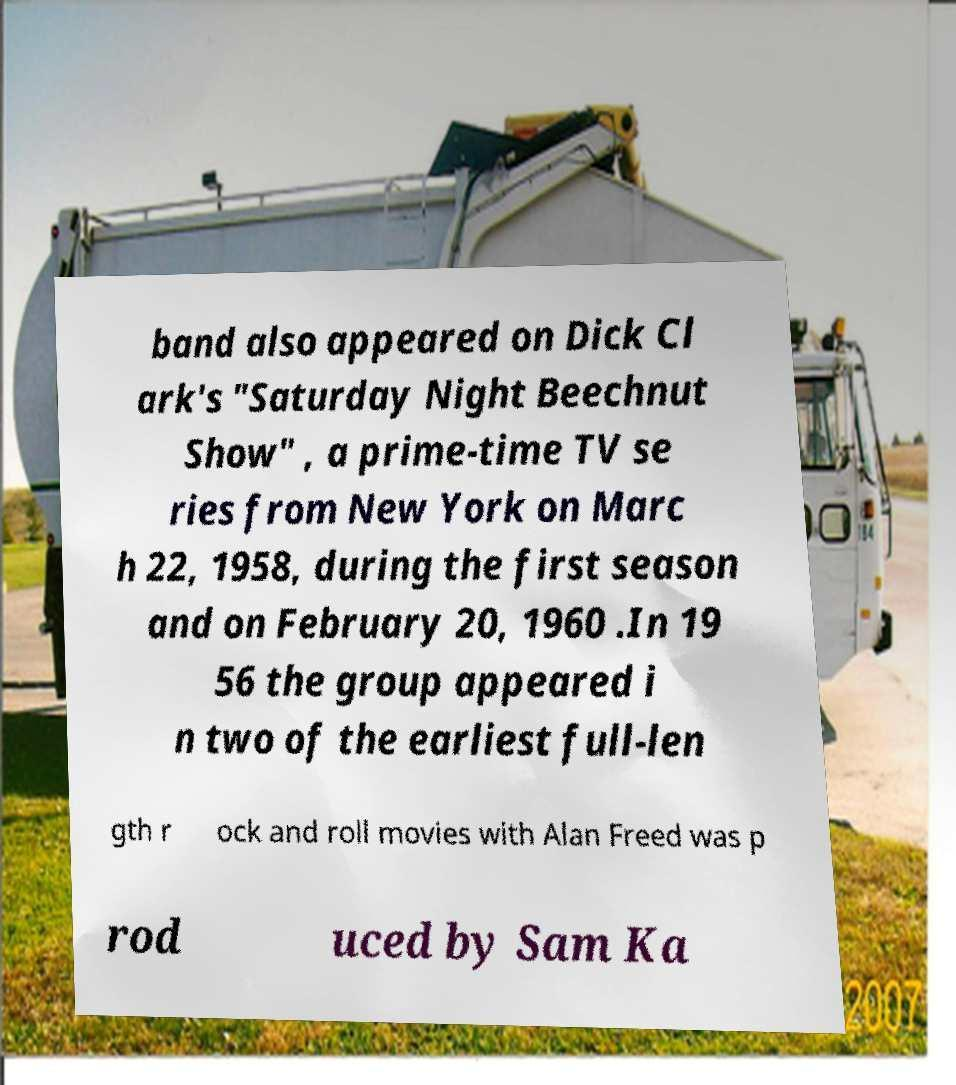For documentation purposes, I need the text within this image transcribed. Could you provide that? band also appeared on Dick Cl ark's "Saturday Night Beechnut Show" , a prime-time TV se ries from New York on Marc h 22, 1958, during the first season and on February 20, 1960 .In 19 56 the group appeared i n two of the earliest full-len gth r ock and roll movies with Alan Freed was p rod uced by Sam Ka 